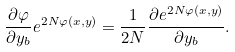<formula> <loc_0><loc_0><loc_500><loc_500>\frac { \partial \varphi } { \partial y _ { b } } e ^ { 2 N \varphi ( x , y ) } = \frac { 1 } { 2 N } \frac { \partial e ^ { 2 N \varphi ( x , y ) } } { \partial y _ { b } } .</formula> 